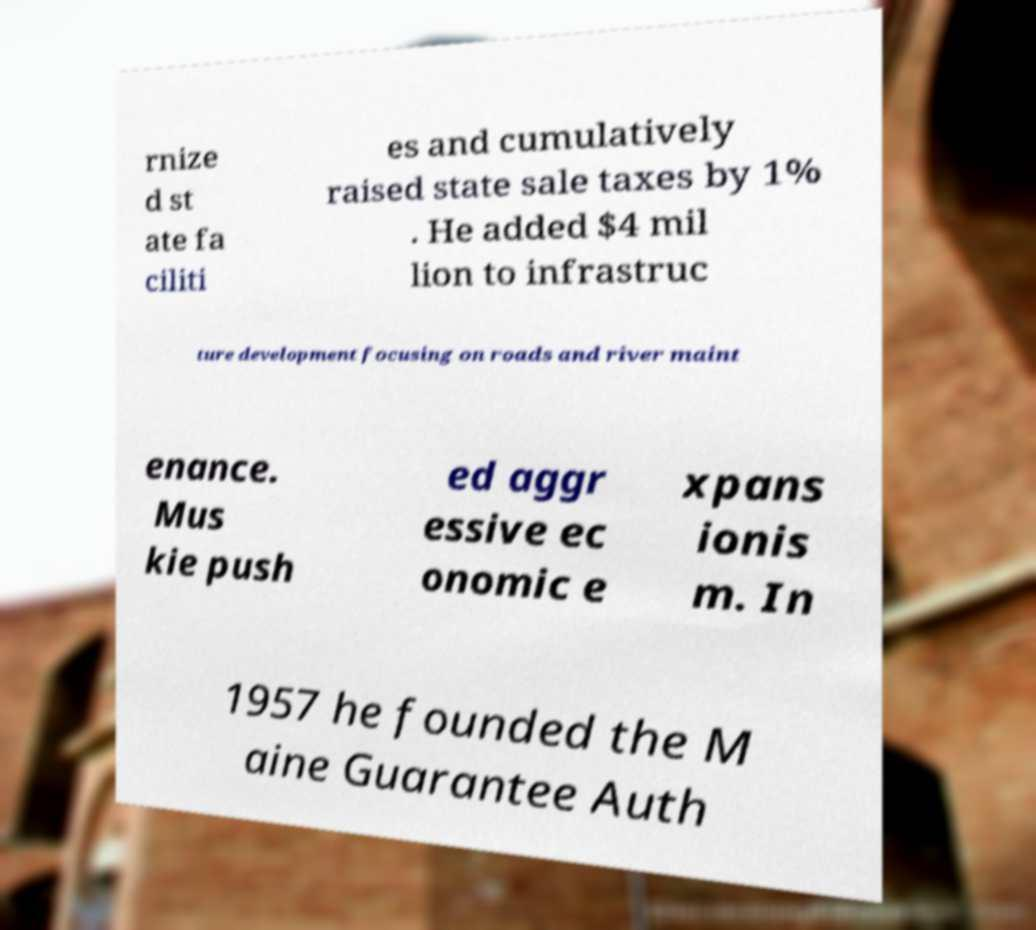I need the written content from this picture converted into text. Can you do that? rnize d st ate fa ciliti es and cumulatively raised state sale taxes by 1% . He added $4 mil lion to infrastruc ture development focusing on roads and river maint enance. Mus kie push ed aggr essive ec onomic e xpans ionis m. In 1957 he founded the M aine Guarantee Auth 